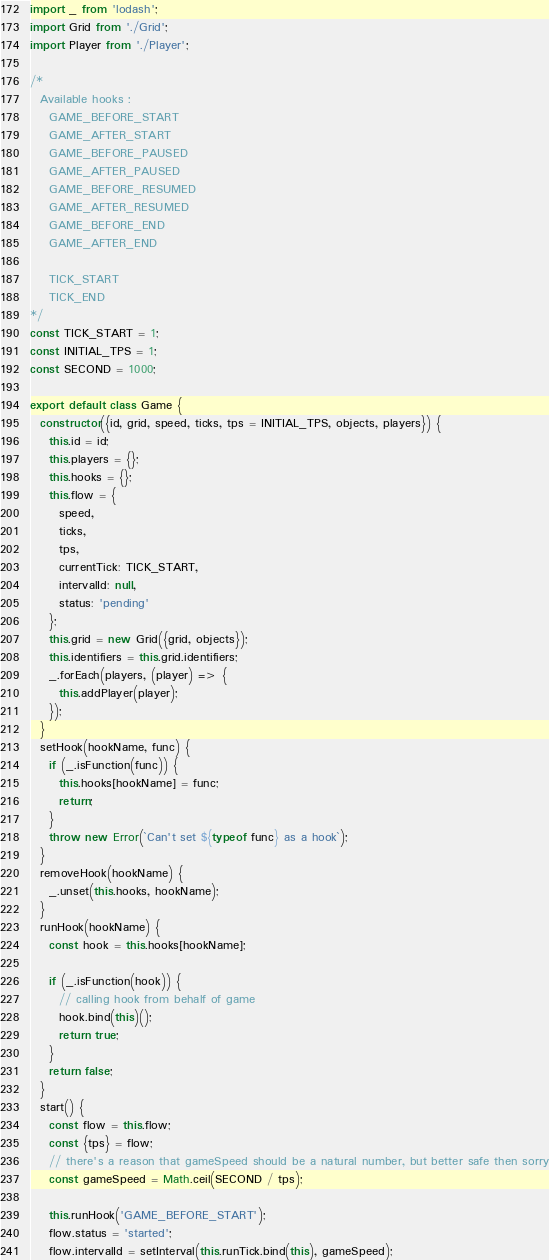Convert code to text. <code><loc_0><loc_0><loc_500><loc_500><_JavaScript_>import _ from 'lodash';
import Grid from './Grid';
import Player from './Player';

/*
  Available hooks :
    GAME_BEFORE_START
    GAME_AFTER_START
    GAME_BEFORE_PAUSED
    GAME_AFTER_PAUSED
    GAME_BEFORE_RESUMED
    GAME_AFTER_RESUMED
    GAME_BEFORE_END
    GAME_AFTER_END

    TICK_START
    TICK_END
*/
const TICK_START = 1;
const INITIAL_TPS = 1;
const SECOND = 1000;

export default class Game {
  constructor({id, grid, speed, ticks, tps = INITIAL_TPS, objects, players}) {
    this.id = id;
    this.players = {};
    this.hooks = {};
    this.flow = {
      speed,
      ticks,
      tps,
      currentTick: TICK_START,
      intervalId: null,
      status: 'pending'
    };
    this.grid = new Grid({grid, objects});
    this.identifiers = this.grid.identifiers;
    _.forEach(players, (player) => {
      this.addPlayer(player);
    });
  }
  setHook(hookName, func) {
    if (_.isFunction(func)) {
      this.hooks[hookName] = func;
      return;
    }
    throw new Error(`Can't set ${typeof func} as a hook`);
  }
  removeHook(hookName) {
    _.unset(this.hooks, hookName);
  }
  runHook(hookName) {
    const hook = this.hooks[hookName];

    if (_.isFunction(hook)) {
      // calling hook from behalf of game
      hook.bind(this)();
      return true;
    }
    return false;
  }
  start() {
    const flow = this.flow;
    const {tps} = flow;
    // there's a reason that gameSpeed should be a natural number, but better safe then sorry
    const gameSpeed = Math.ceil(SECOND / tps);

    this.runHook('GAME_BEFORE_START');
    flow.status = 'started';
    flow.intervalId = setInterval(this.runTick.bind(this), gameSpeed);</code> 